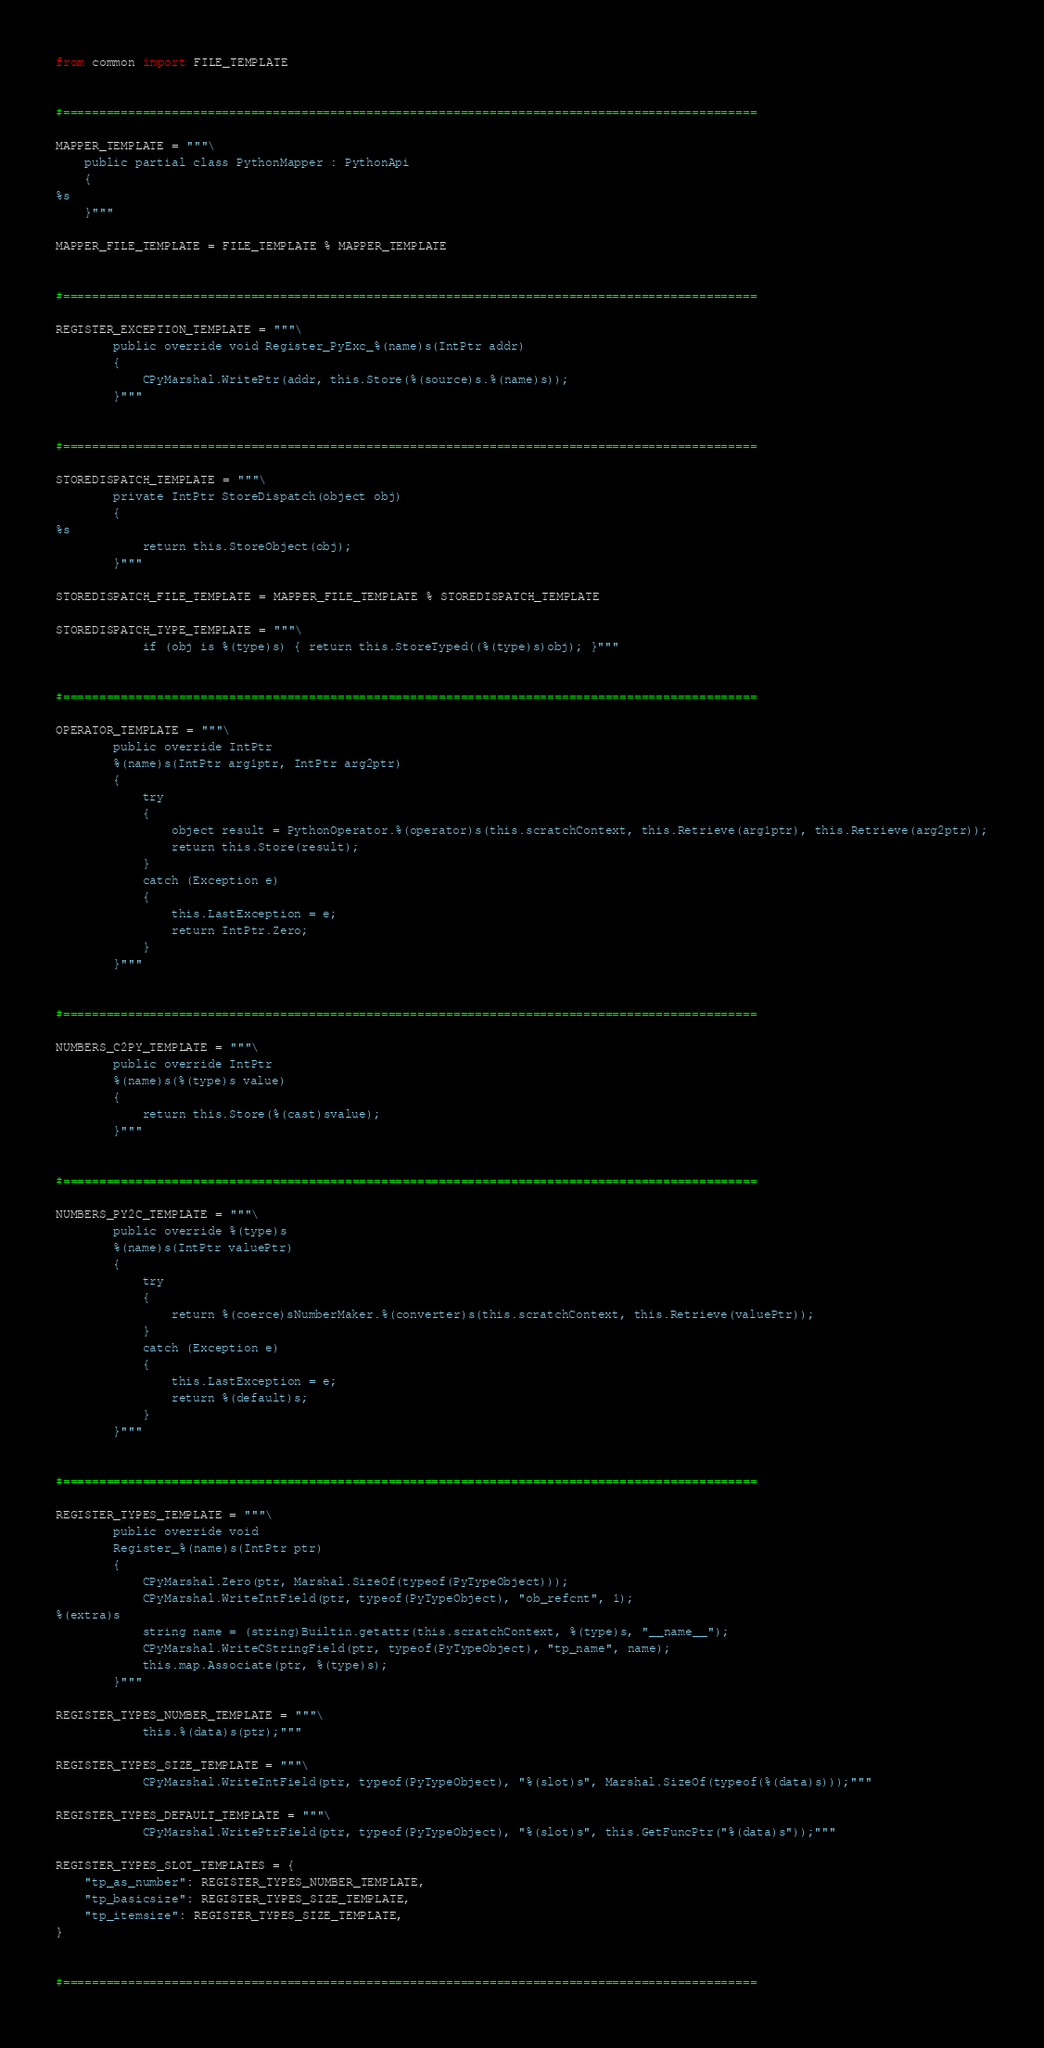Convert code to text. <code><loc_0><loc_0><loc_500><loc_500><_Python_>
from common import FILE_TEMPLATE


#================================================================================================

MAPPER_TEMPLATE = """\
    public partial class PythonMapper : PythonApi
    {
%s
    }"""

MAPPER_FILE_TEMPLATE = FILE_TEMPLATE % MAPPER_TEMPLATE


#================================================================================================

REGISTER_EXCEPTION_TEMPLATE = """\
        public override void Register_PyExc_%(name)s(IntPtr addr)
        {
            CPyMarshal.WritePtr(addr, this.Store(%(source)s.%(name)s));
        }"""


#================================================================================================

STOREDISPATCH_TEMPLATE = """\
        private IntPtr StoreDispatch(object obj)
        {
%s
            return this.StoreObject(obj);
        }"""

STOREDISPATCH_FILE_TEMPLATE = MAPPER_FILE_TEMPLATE % STOREDISPATCH_TEMPLATE

STOREDISPATCH_TYPE_TEMPLATE = """\
            if (obj is %(type)s) { return this.StoreTyped((%(type)s)obj); }"""


#================================================================================================

OPERATOR_TEMPLATE = """\
        public override IntPtr
        %(name)s(IntPtr arg1ptr, IntPtr arg2ptr)
        {
            try
            {
                object result = PythonOperator.%(operator)s(this.scratchContext, this.Retrieve(arg1ptr), this.Retrieve(arg2ptr));
                return this.Store(result);
            }
            catch (Exception e)
            {
                this.LastException = e;
                return IntPtr.Zero;
            }
        }"""


#================================================================================================

NUMBERS_C2PY_TEMPLATE = """\
        public override IntPtr
        %(name)s(%(type)s value)
        {
            return this.Store(%(cast)svalue);
        }"""


#================================================================================================

NUMBERS_PY2C_TEMPLATE = """\
        public override %(type)s
        %(name)s(IntPtr valuePtr)
        {
            try
            {
                return %(coerce)sNumberMaker.%(converter)s(this.scratchContext, this.Retrieve(valuePtr));
            }
            catch (Exception e)
            {
                this.LastException = e;
                return %(default)s;
            }
        }"""


#================================================================================================

REGISTER_TYPES_TEMPLATE = """\
        public override void
        Register_%(name)s(IntPtr ptr)
        {
            CPyMarshal.Zero(ptr, Marshal.SizeOf(typeof(PyTypeObject)));
            CPyMarshal.WriteIntField(ptr, typeof(PyTypeObject), "ob_refcnt", 1);
%(extra)s
            string name = (string)Builtin.getattr(this.scratchContext, %(type)s, "__name__");
            CPyMarshal.WriteCStringField(ptr, typeof(PyTypeObject), "tp_name", name);
            this.map.Associate(ptr, %(type)s);
        }"""

REGISTER_TYPES_NUMBER_TEMPLATE = """\
            this.%(data)s(ptr);"""

REGISTER_TYPES_SIZE_TEMPLATE = """\
            CPyMarshal.WriteIntField(ptr, typeof(PyTypeObject), "%(slot)s", Marshal.SizeOf(typeof(%(data)s)));"""

REGISTER_TYPES_DEFAULT_TEMPLATE = """\
            CPyMarshal.WritePtrField(ptr, typeof(PyTypeObject), "%(slot)s", this.GetFuncPtr("%(data)s"));"""

REGISTER_TYPES_SLOT_TEMPLATES = {
    "tp_as_number": REGISTER_TYPES_NUMBER_TEMPLATE,
    "tp_basicsize": REGISTER_TYPES_SIZE_TEMPLATE,
    "tp_itemsize": REGISTER_TYPES_SIZE_TEMPLATE,
}


#================================================================================================
</code> 